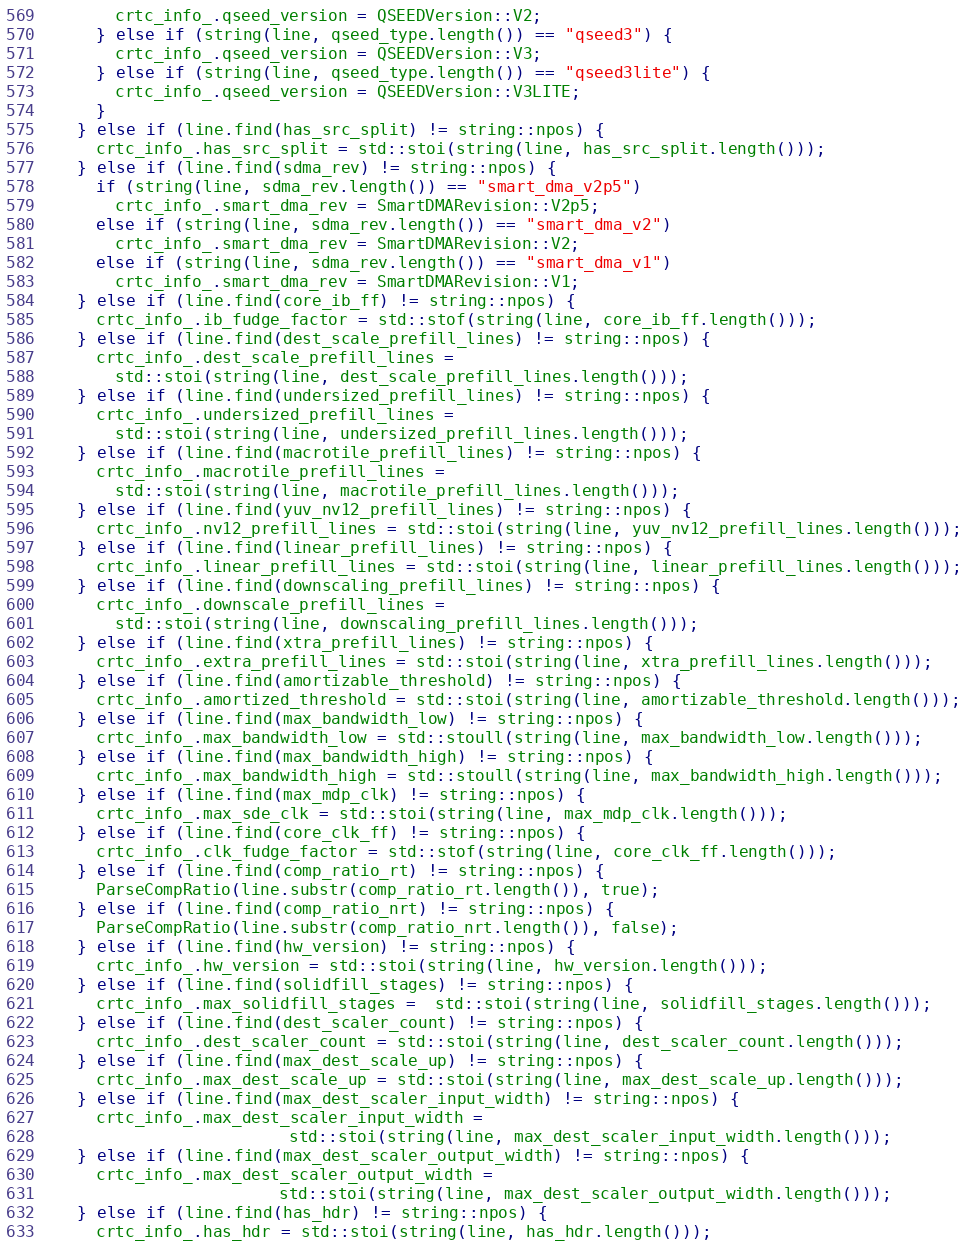Convert code to text. <code><loc_0><loc_0><loc_500><loc_500><_C++_>        crtc_info_.qseed_version = QSEEDVersion::V2;
      } else if (string(line, qseed_type.length()) == "qseed3") {
        crtc_info_.qseed_version = QSEEDVersion::V3;
      } else if (string(line, qseed_type.length()) == "qseed3lite") {
        crtc_info_.qseed_version = QSEEDVersion::V3LITE;
      }
    } else if (line.find(has_src_split) != string::npos) {
      crtc_info_.has_src_split = std::stoi(string(line, has_src_split.length()));
    } else if (line.find(sdma_rev) != string::npos) {
      if (string(line, sdma_rev.length()) == "smart_dma_v2p5")
        crtc_info_.smart_dma_rev = SmartDMARevision::V2p5;
      else if (string(line, sdma_rev.length()) == "smart_dma_v2")
        crtc_info_.smart_dma_rev = SmartDMARevision::V2;
      else if (string(line, sdma_rev.length()) == "smart_dma_v1")
        crtc_info_.smart_dma_rev = SmartDMARevision::V1;
    } else if (line.find(core_ib_ff) != string::npos) {
      crtc_info_.ib_fudge_factor = std::stof(string(line, core_ib_ff.length()));
    } else if (line.find(dest_scale_prefill_lines) != string::npos) {
      crtc_info_.dest_scale_prefill_lines =
        std::stoi(string(line, dest_scale_prefill_lines.length()));
    } else if (line.find(undersized_prefill_lines) != string::npos) {
      crtc_info_.undersized_prefill_lines =
        std::stoi(string(line, undersized_prefill_lines.length()));
    } else if (line.find(macrotile_prefill_lines) != string::npos) {
      crtc_info_.macrotile_prefill_lines =
        std::stoi(string(line, macrotile_prefill_lines.length()));
    } else if (line.find(yuv_nv12_prefill_lines) != string::npos) {
      crtc_info_.nv12_prefill_lines = std::stoi(string(line, yuv_nv12_prefill_lines.length()));
    } else if (line.find(linear_prefill_lines) != string::npos) {
      crtc_info_.linear_prefill_lines = std::stoi(string(line, linear_prefill_lines.length()));
    } else if (line.find(downscaling_prefill_lines) != string::npos) {
      crtc_info_.downscale_prefill_lines =
        std::stoi(string(line, downscaling_prefill_lines.length()));
    } else if (line.find(xtra_prefill_lines) != string::npos) {
      crtc_info_.extra_prefill_lines = std::stoi(string(line, xtra_prefill_lines.length()));
    } else if (line.find(amortizable_threshold) != string::npos) {
      crtc_info_.amortized_threshold = std::stoi(string(line, amortizable_threshold.length()));
    } else if (line.find(max_bandwidth_low) != string::npos) {
      crtc_info_.max_bandwidth_low = std::stoull(string(line, max_bandwidth_low.length()));
    } else if (line.find(max_bandwidth_high) != string::npos) {
      crtc_info_.max_bandwidth_high = std::stoull(string(line, max_bandwidth_high.length()));
    } else if (line.find(max_mdp_clk) != string::npos) {
      crtc_info_.max_sde_clk = std::stoi(string(line, max_mdp_clk.length()));
    } else if (line.find(core_clk_ff) != string::npos) {
      crtc_info_.clk_fudge_factor = std::stof(string(line, core_clk_ff.length()));
    } else if (line.find(comp_ratio_rt) != string::npos) {
      ParseCompRatio(line.substr(comp_ratio_rt.length()), true);
    } else if (line.find(comp_ratio_nrt) != string::npos) {
      ParseCompRatio(line.substr(comp_ratio_nrt.length()), false);
    } else if (line.find(hw_version) != string::npos) {
      crtc_info_.hw_version = std::stoi(string(line, hw_version.length()));
    } else if (line.find(solidfill_stages) != string::npos) {
      crtc_info_.max_solidfill_stages =  std::stoi(string(line, solidfill_stages.length()));
    } else if (line.find(dest_scaler_count) != string::npos) {
      crtc_info_.dest_scaler_count = std::stoi(string(line, dest_scaler_count.length()));
    } else if (line.find(max_dest_scale_up) != string::npos) {
      crtc_info_.max_dest_scale_up = std::stoi(string(line, max_dest_scale_up.length()));
    } else if (line.find(max_dest_scaler_input_width) != string::npos) {
      crtc_info_.max_dest_scaler_input_width =
                          std::stoi(string(line, max_dest_scaler_input_width.length()));
    } else if (line.find(max_dest_scaler_output_width) != string::npos) {
      crtc_info_.max_dest_scaler_output_width =
                         std::stoi(string(line, max_dest_scaler_output_width.length()));
    } else if (line.find(has_hdr) != string::npos) {
      crtc_info_.has_hdr = std::stoi(string(line, has_hdr.length()));</code> 